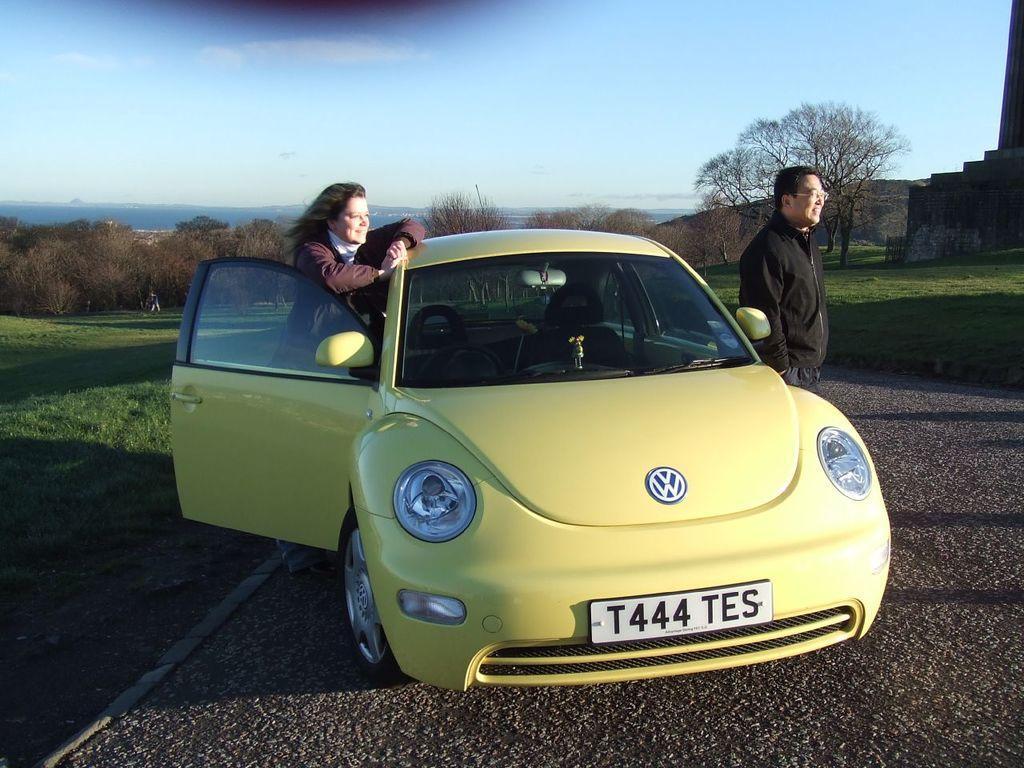Could you give a brief overview of what you see in this image? In this image there is a car on a road, on either side of the car there are two people standing, on either side of the road there is grassland, in the background there are and the sky. 